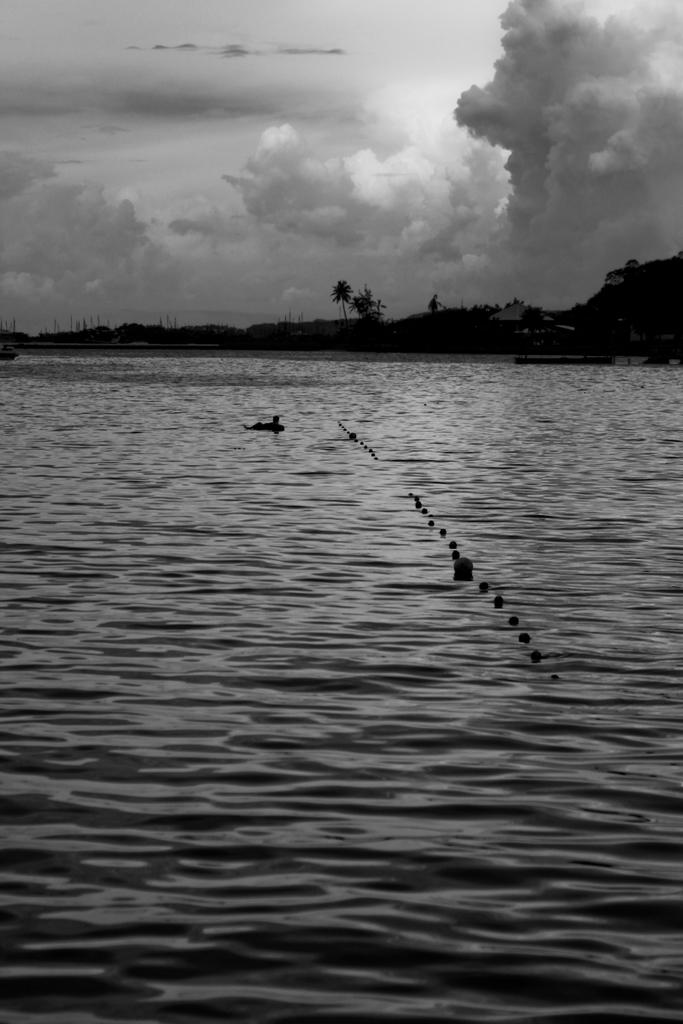What is at the bottom of the image? There is a sea at the bottom of the image. What can be seen in the sea? There are birds in the sea. What type of vegetation is visible in the background of the image? There are trees in the background of the image. What structures can be seen in the background of the image? There are poles in the background of the image. What is visible at the top of the image? The sky is visible at the top of the image. What is the condition of the brass in the image? There is no brass present in the image. Can you tell me how many balloons are floating in the sea? There are no balloons present in the image; it features birds in the sea. 